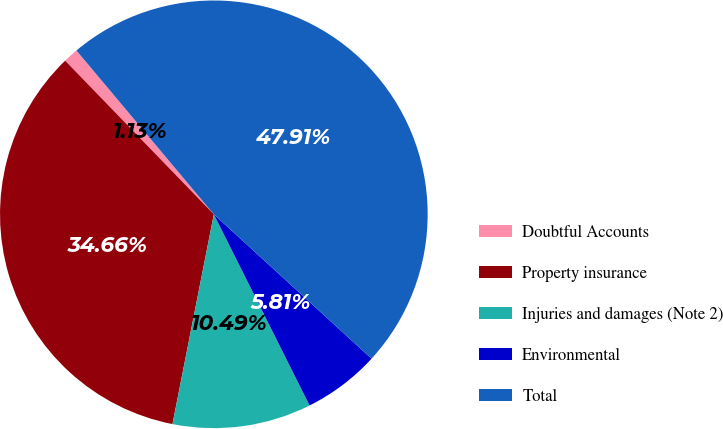<chart> <loc_0><loc_0><loc_500><loc_500><pie_chart><fcel>Doubtful Accounts<fcel>Property insurance<fcel>Injuries and damages (Note 2)<fcel>Environmental<fcel>Total<nl><fcel>1.13%<fcel>34.66%<fcel>10.49%<fcel>5.81%<fcel>47.91%<nl></chart> 